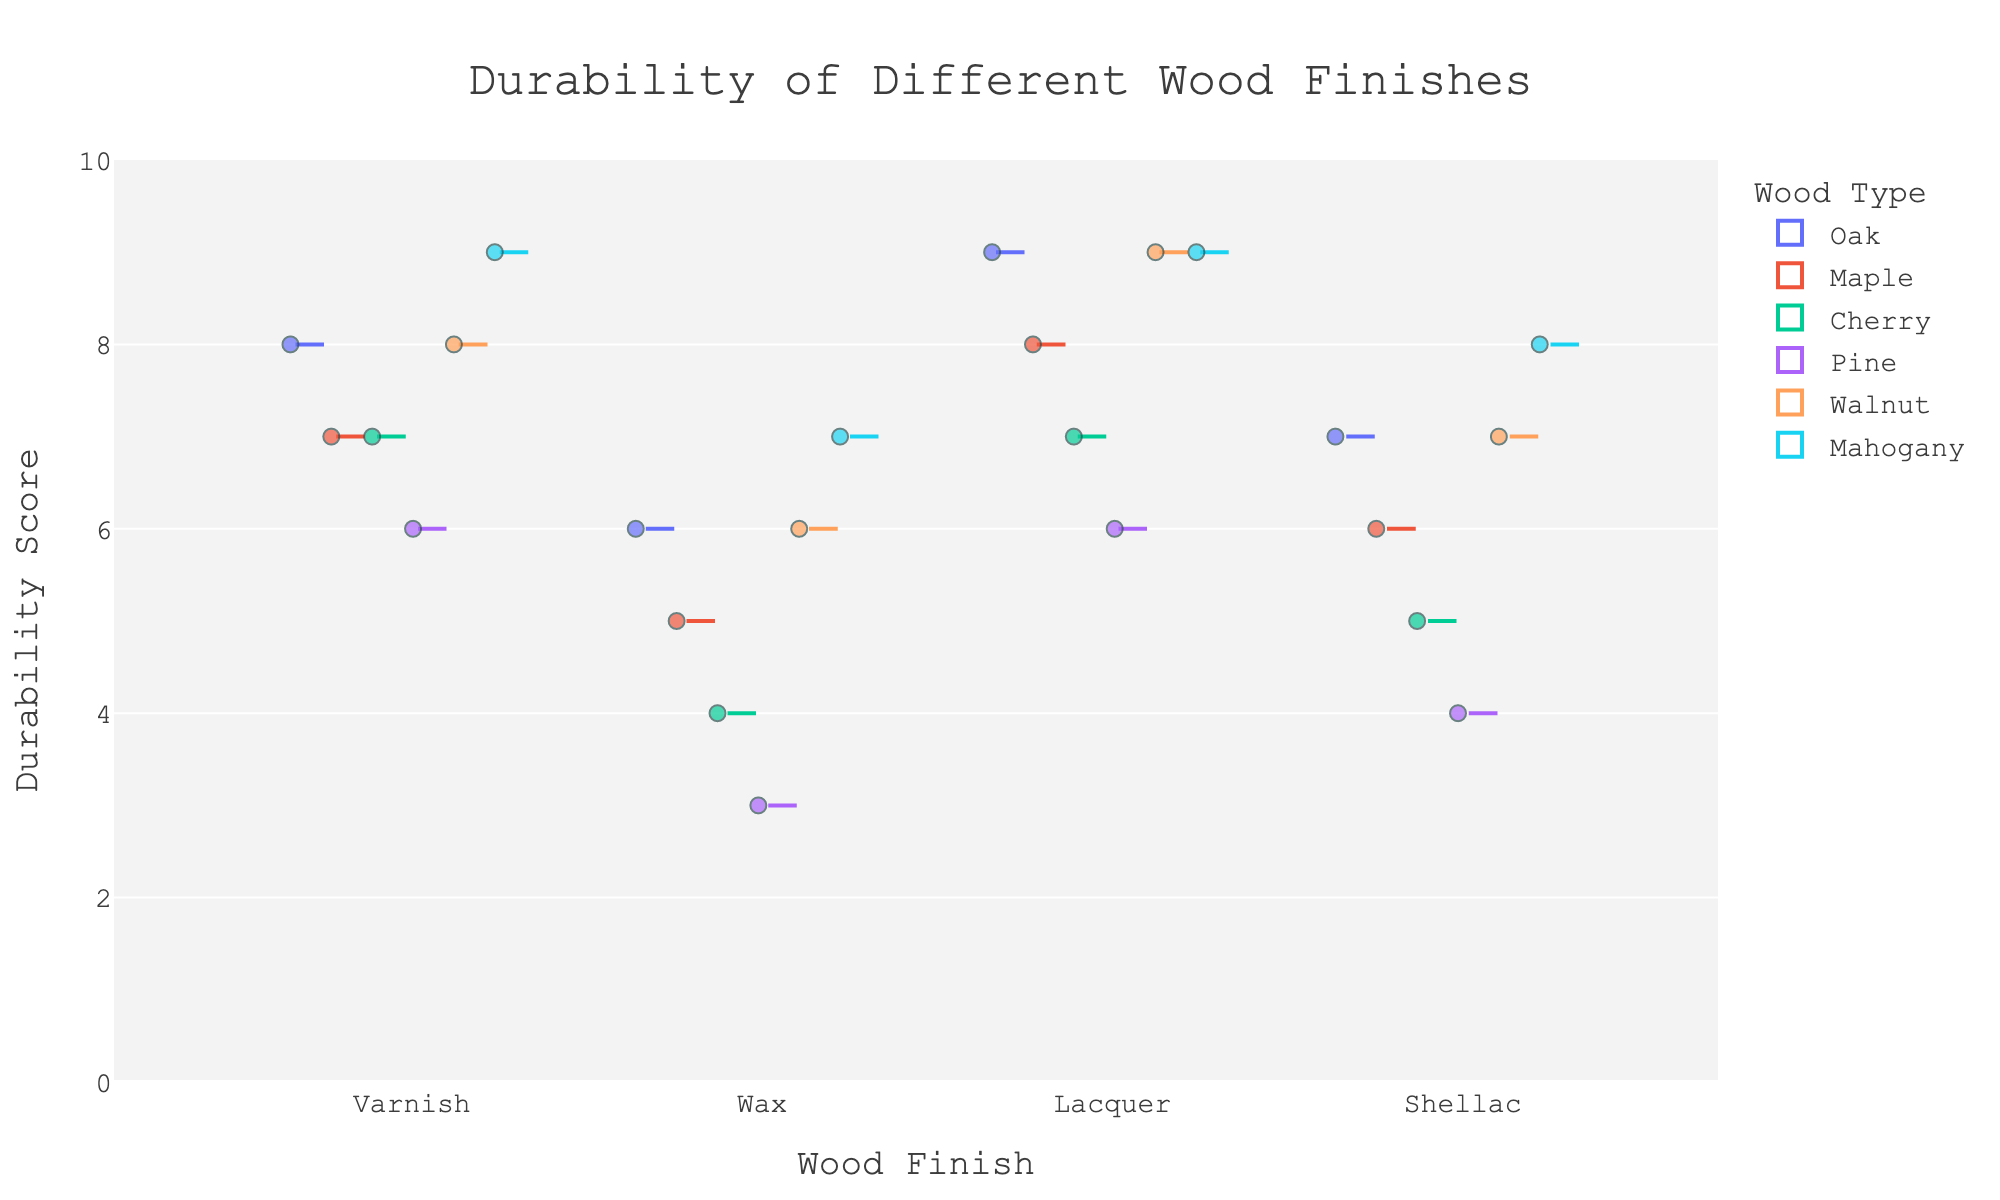What is the title of the plot? The title is usually located at the top of the plot. In this case, it reads "Durability of Different Wood Finishes" which is clearly shown.
Answer: Durability of Different Wood Finishes Which wood finish has the highest median durability? To find the median durability, look for the line inside the box that splits each box plot. The Lacquer finish consistently shows the highest median across the different wood types.
Answer: Lacquer How many wood types are represented in the plot? Each color on the plot represents a different wood type. There are six colors, each representing Oak, Maple, Cherry, Pine, Walnut, and Mahogany.
Answer: Six What is the range of durability scores for the Varnish finish on Pine? You can observe the range by checking the bottom and top of the box plot whiskers for the Varnish finish on Pine. The whiskers extend from 6 to 6, indicating no range.
Answer: 6-6 Which wood type shows the largest variation in durability for the Wax finish? Variation is shown by the length of the box and whiskers. Cherry shows the largest variation for the Wax finish as its box and whisker length are the largest.
Answer: Cherry Which wood type has the highest single durability score, and for which finish? Look for the highest point on the y-axis. Mahogany with Lacquer has the highest durability score of 9.
Answer: Mahogany with Lacquer What is the median durability for Shellac finish on Maple? The median value is the line inside the box plot. For Maple with Shellac, the median is at 6.
Answer: 6 How does the durability of Wax in Pine compare to the durability of Shellac in Cherry? Compare the medians and ranges of the two finishes. Pine with Wax has a median of 3 while Cherry with Shellac has a median of 5, so Cherry with Shellac is more durable.
Answer: Cherry with Shellac is more durable Which wood type has the lowest overall durability score for any finish, and what is the score? Look for the lowest point on the y-axis. Pine with Wax has the lowest durability score of 3.
Answer: Pine with Wax What is the interquartile range (IQR) of durability for the Varnish finish on Oak? IQR is the distance between the first quartile (Q1) and the third quartile (Q3). For Oak with Varnish, the box stretches from about 7 to 9. The IQR is 9 - 7 = 2.
Answer: 2 